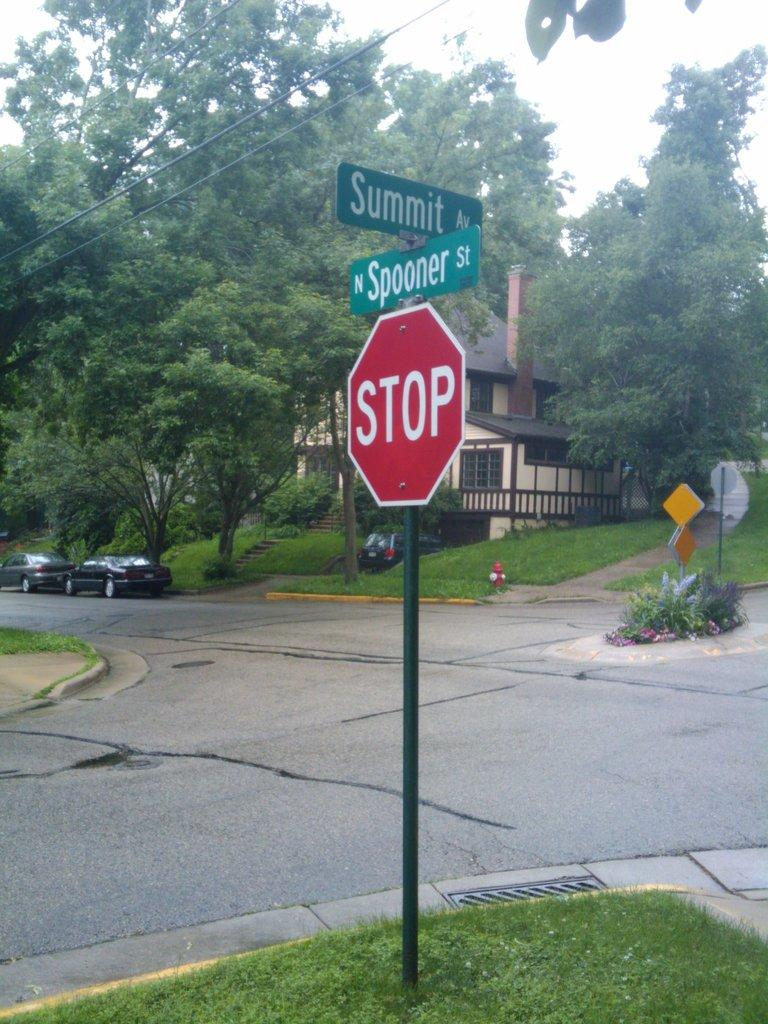<image>
Create a compact narrative representing the image presented. a stop sign that is in a very green neighborhood 